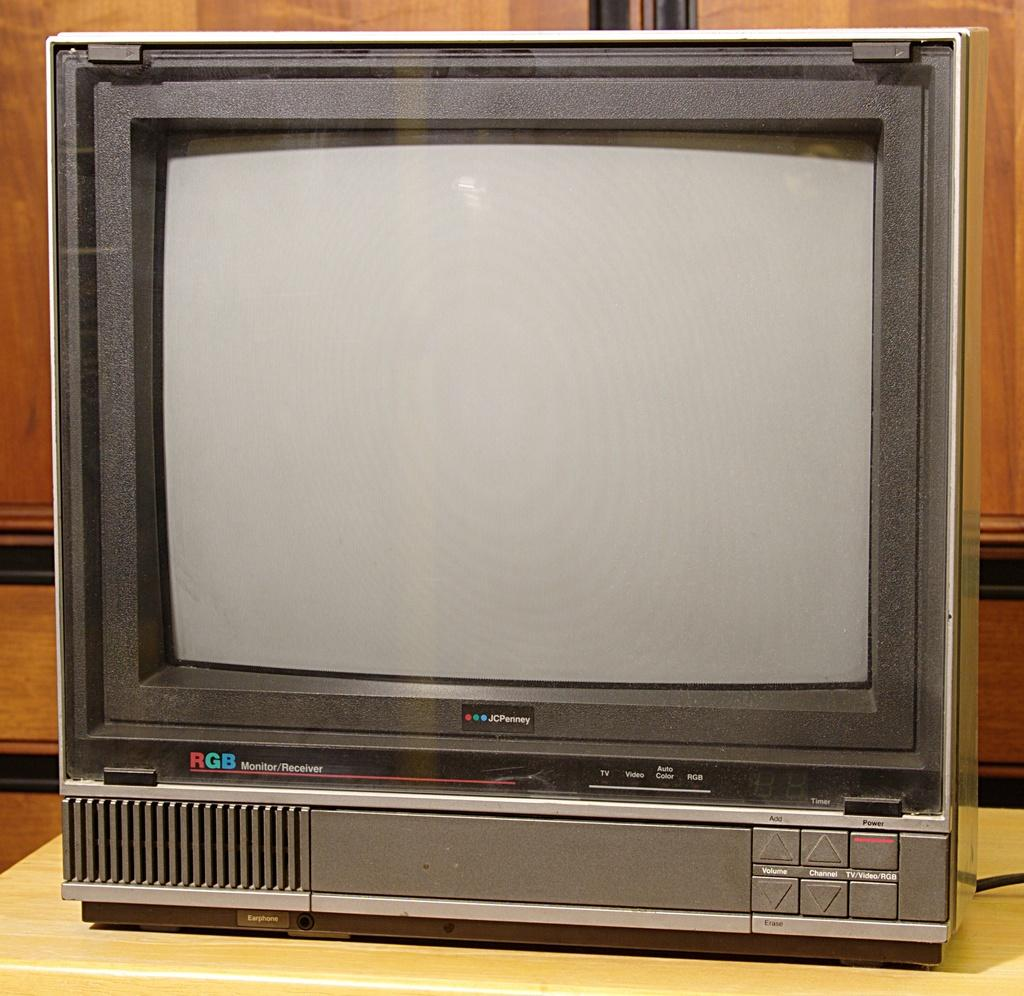<image>
Provide a brief description of the given image. An old JC Penny television has a built in VCR. 